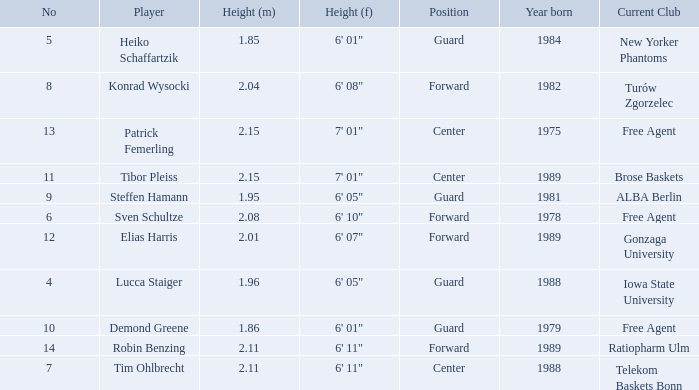Name the height for the player born in 1981 1.95. 